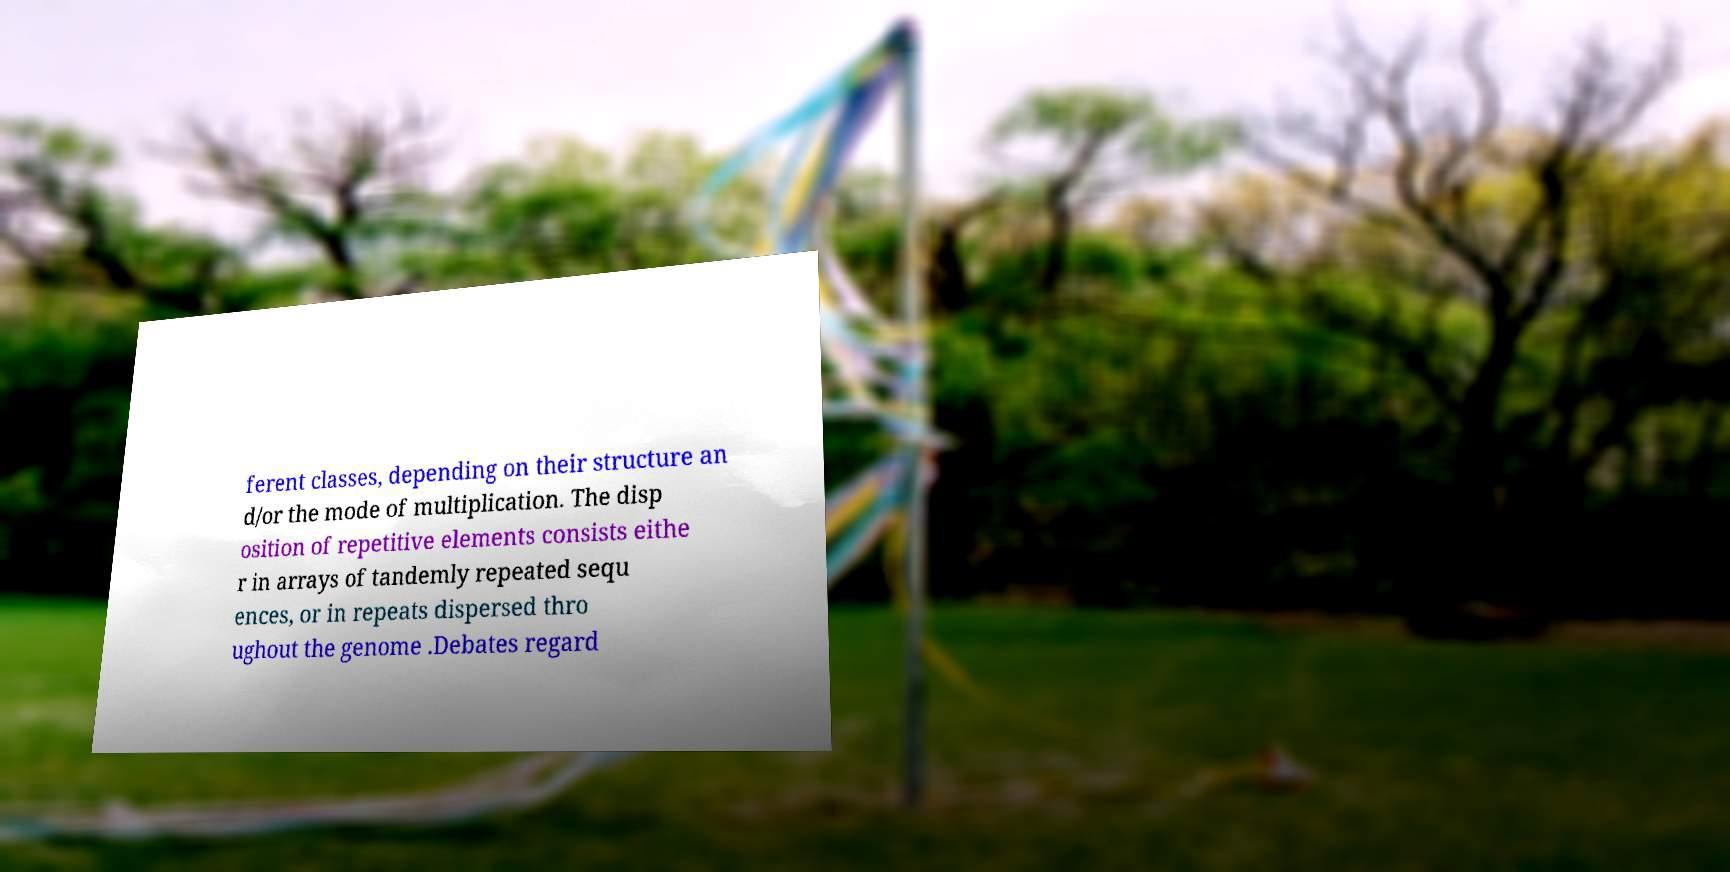I need the written content from this picture converted into text. Can you do that? ferent classes, depending on their structure an d/or the mode of multiplication. The disp osition of repetitive elements consists eithe r in arrays of tandemly repeated sequ ences, or in repeats dispersed thro ughout the genome .Debates regard 